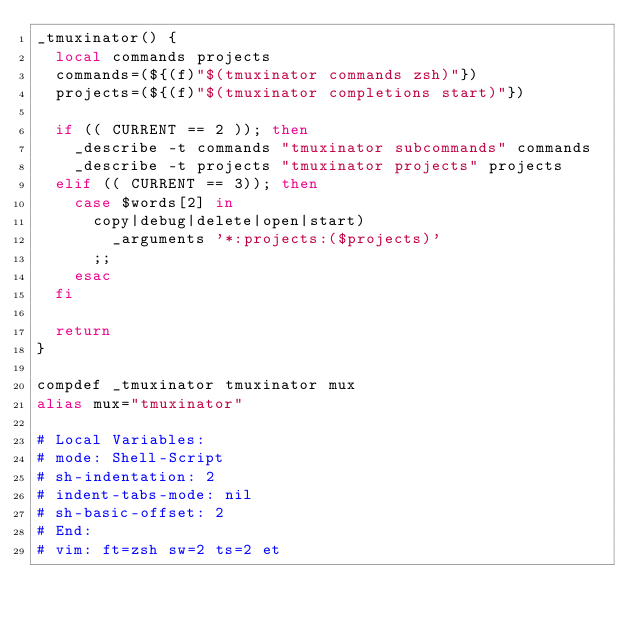Convert code to text. <code><loc_0><loc_0><loc_500><loc_500><_Bash_>_tmuxinator() {
  local commands projects
  commands=(${(f)"$(tmuxinator commands zsh)"})
  projects=(${(f)"$(tmuxinator completions start)"})

  if (( CURRENT == 2 )); then
    _describe -t commands "tmuxinator subcommands" commands
    _describe -t projects "tmuxinator projects" projects
  elif (( CURRENT == 3)); then
    case $words[2] in
      copy|debug|delete|open|start)
        _arguments '*:projects:($projects)'
      ;;
    esac
  fi

  return
}

compdef _tmuxinator tmuxinator mux
alias mux="tmuxinator"

# Local Variables:
# mode: Shell-Script
# sh-indentation: 2
# indent-tabs-mode: nil
# sh-basic-offset: 2
# End:
# vim: ft=zsh sw=2 ts=2 et
</code> 